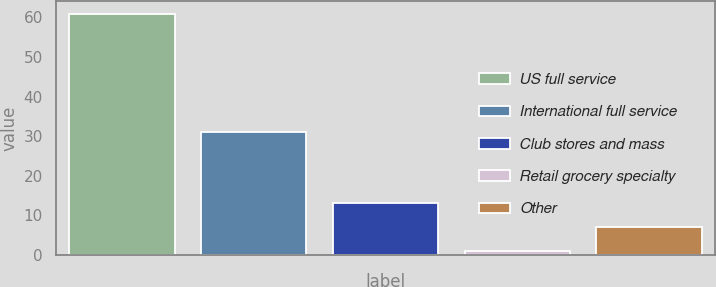Convert chart. <chart><loc_0><loc_0><loc_500><loc_500><bar_chart><fcel>US full service<fcel>International full service<fcel>Club stores and mass<fcel>Retail grocery specialty<fcel>Other<nl><fcel>61<fcel>31<fcel>13<fcel>1<fcel>7<nl></chart> 